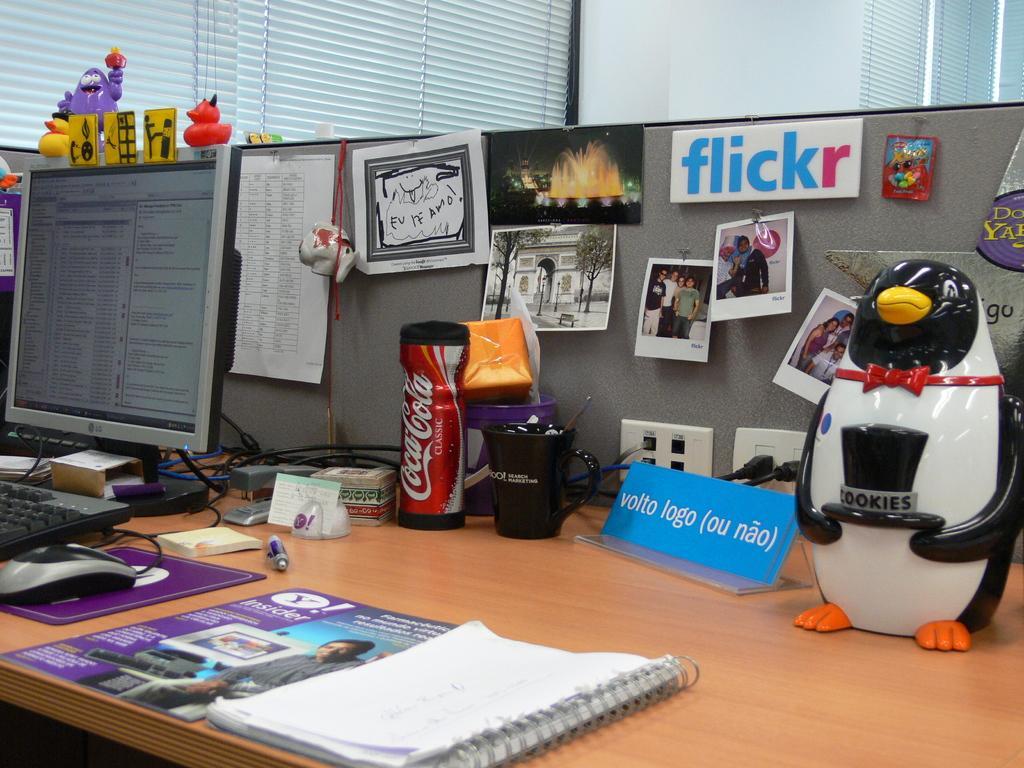Please provide a concise description of this image. There is a table in this picture on which some books, palm plates, name plates, toys, cups, bottles and some papers are placed. There is a monitor, keyboard and mouse here. In the background there is a curtain and a wall here. 